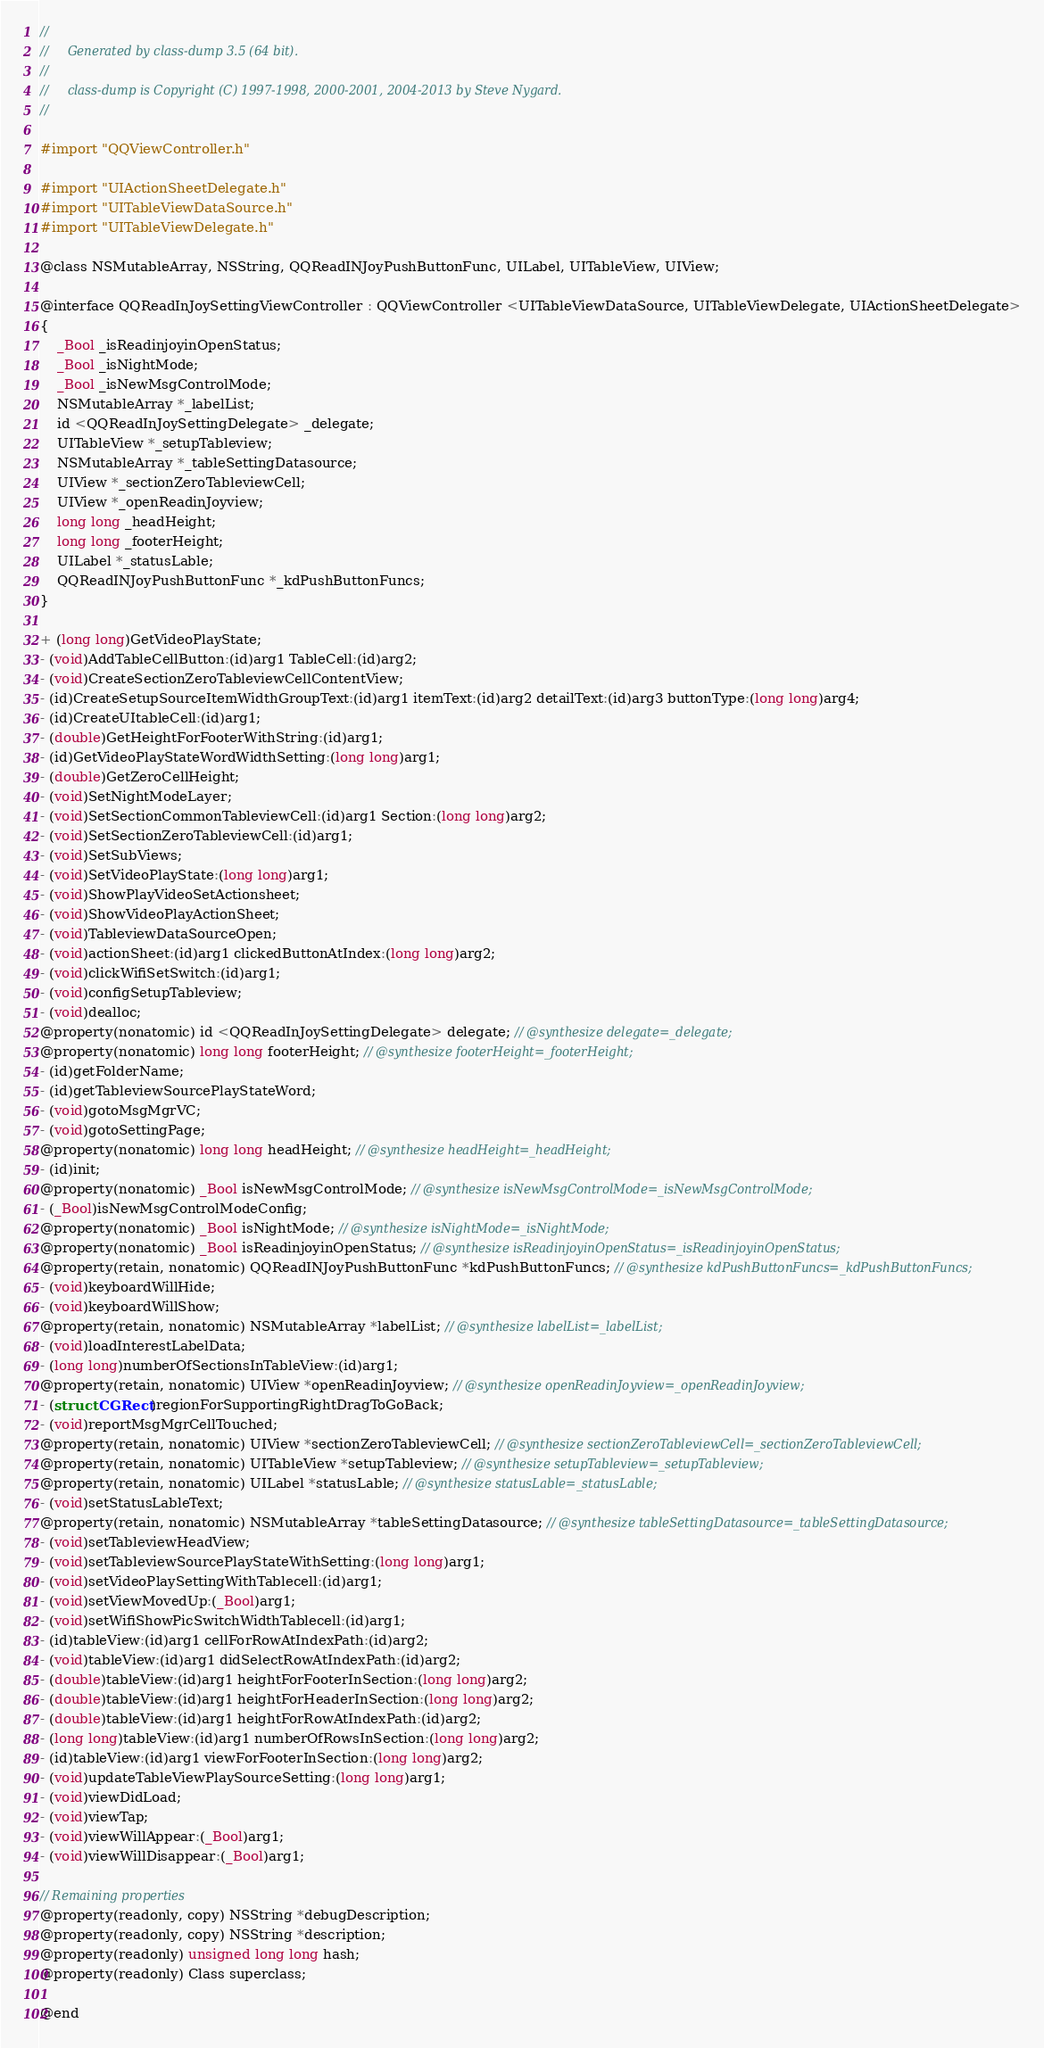Convert code to text. <code><loc_0><loc_0><loc_500><loc_500><_C_>//
//     Generated by class-dump 3.5 (64 bit).
//
//     class-dump is Copyright (C) 1997-1998, 2000-2001, 2004-2013 by Steve Nygard.
//

#import "QQViewController.h"

#import "UIActionSheetDelegate.h"
#import "UITableViewDataSource.h"
#import "UITableViewDelegate.h"

@class NSMutableArray, NSString, QQReadINJoyPushButtonFunc, UILabel, UITableView, UIView;

@interface QQReadInJoySettingViewController : QQViewController <UITableViewDataSource, UITableViewDelegate, UIActionSheetDelegate>
{
    _Bool _isReadinjoyinOpenStatus;
    _Bool _isNightMode;
    _Bool _isNewMsgControlMode;
    NSMutableArray *_labelList;
    id <QQReadInJoySettingDelegate> _delegate;
    UITableView *_setupTableview;
    NSMutableArray *_tableSettingDatasource;
    UIView *_sectionZeroTableviewCell;
    UIView *_openReadinJoyview;
    long long _headHeight;
    long long _footerHeight;
    UILabel *_statusLable;
    QQReadINJoyPushButtonFunc *_kdPushButtonFuncs;
}

+ (long long)GetVideoPlayState;
- (void)AddTableCellButton:(id)arg1 TableCell:(id)arg2;
- (void)CreateSectionZeroTableviewCellContentView;
- (id)CreateSetupSourceItemWidthGroupText:(id)arg1 itemText:(id)arg2 detailText:(id)arg3 buttonType:(long long)arg4;
- (id)CreateUItableCell:(id)arg1;
- (double)GetHeightForFooterWithString:(id)arg1;
- (id)GetVideoPlayStateWordWidthSetting:(long long)arg1;
- (double)GetZeroCellHeight;
- (void)SetNightModeLayer;
- (void)SetSectionCommonTableviewCell:(id)arg1 Section:(long long)arg2;
- (void)SetSectionZeroTableviewCell:(id)arg1;
- (void)SetSubViews;
- (void)SetVideoPlayState:(long long)arg1;
- (void)ShowPlayVideoSetActionsheet;
- (void)ShowVideoPlayActionSheet;
- (void)TableviewDataSourceOpen;
- (void)actionSheet:(id)arg1 clickedButtonAtIndex:(long long)arg2;
- (void)clickWifiSetSwitch:(id)arg1;
- (void)configSetupTableview;
- (void)dealloc;
@property(nonatomic) id <QQReadInJoySettingDelegate> delegate; // @synthesize delegate=_delegate;
@property(nonatomic) long long footerHeight; // @synthesize footerHeight=_footerHeight;
- (id)getFolderName;
- (id)getTableviewSourcePlayStateWord;
- (void)gotoMsgMgrVC;
- (void)gotoSettingPage;
@property(nonatomic) long long headHeight; // @synthesize headHeight=_headHeight;
- (id)init;
@property(nonatomic) _Bool isNewMsgControlMode; // @synthesize isNewMsgControlMode=_isNewMsgControlMode;
- (_Bool)isNewMsgControlModeConfig;
@property(nonatomic) _Bool isNightMode; // @synthesize isNightMode=_isNightMode;
@property(nonatomic) _Bool isReadinjoyinOpenStatus; // @synthesize isReadinjoyinOpenStatus=_isReadinjoyinOpenStatus;
@property(retain, nonatomic) QQReadINJoyPushButtonFunc *kdPushButtonFuncs; // @synthesize kdPushButtonFuncs=_kdPushButtonFuncs;
- (void)keyboardWillHide;
- (void)keyboardWillShow;
@property(retain, nonatomic) NSMutableArray *labelList; // @synthesize labelList=_labelList;
- (void)loadInterestLabelData;
- (long long)numberOfSectionsInTableView:(id)arg1;
@property(retain, nonatomic) UIView *openReadinJoyview; // @synthesize openReadinJoyview=_openReadinJoyview;
- (struct CGRect)regionForSupportingRightDragToGoBack;
- (void)reportMsgMgrCellTouched;
@property(retain, nonatomic) UIView *sectionZeroTableviewCell; // @synthesize sectionZeroTableviewCell=_sectionZeroTableviewCell;
@property(retain, nonatomic) UITableView *setupTableview; // @synthesize setupTableview=_setupTableview;
@property(retain, nonatomic) UILabel *statusLable; // @synthesize statusLable=_statusLable;
- (void)setStatusLableText;
@property(retain, nonatomic) NSMutableArray *tableSettingDatasource; // @synthesize tableSettingDatasource=_tableSettingDatasource;
- (void)setTableviewHeadView;
- (void)setTableviewSourcePlayStateWithSetting:(long long)arg1;
- (void)setVideoPlaySettingWithTablecell:(id)arg1;
- (void)setViewMovedUp:(_Bool)arg1;
- (void)setWifiShowPicSwitchWidthTablecell:(id)arg1;
- (id)tableView:(id)arg1 cellForRowAtIndexPath:(id)arg2;
- (void)tableView:(id)arg1 didSelectRowAtIndexPath:(id)arg2;
- (double)tableView:(id)arg1 heightForFooterInSection:(long long)arg2;
- (double)tableView:(id)arg1 heightForHeaderInSection:(long long)arg2;
- (double)tableView:(id)arg1 heightForRowAtIndexPath:(id)arg2;
- (long long)tableView:(id)arg1 numberOfRowsInSection:(long long)arg2;
- (id)tableView:(id)arg1 viewForFooterInSection:(long long)arg2;
- (void)updateTableViewPlaySourceSetting:(long long)arg1;
- (void)viewDidLoad;
- (void)viewTap;
- (void)viewWillAppear:(_Bool)arg1;
- (void)viewWillDisappear:(_Bool)arg1;

// Remaining properties
@property(readonly, copy) NSString *debugDescription;
@property(readonly, copy) NSString *description;
@property(readonly) unsigned long long hash;
@property(readonly) Class superclass;

@end

</code> 